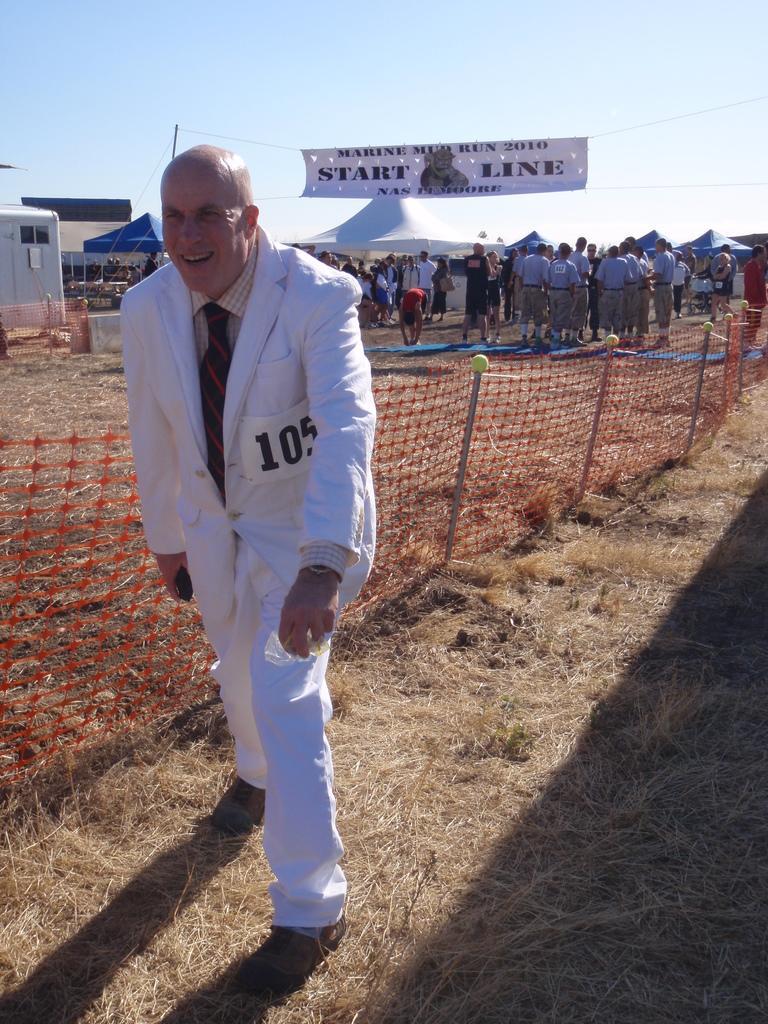How would you summarize this image in a sentence or two? In this picture there is a person wearing white dress is standing on a dried grass and there are few people,tents and a banner which has something written on it is in the background. 